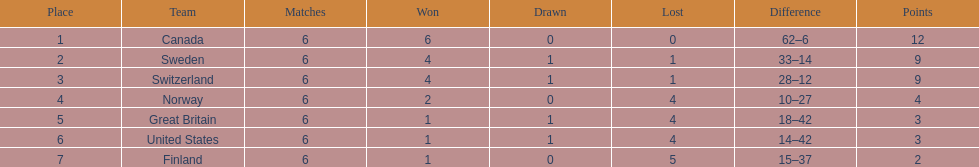Which nation experienced the least number of goals conceded? Finland. 